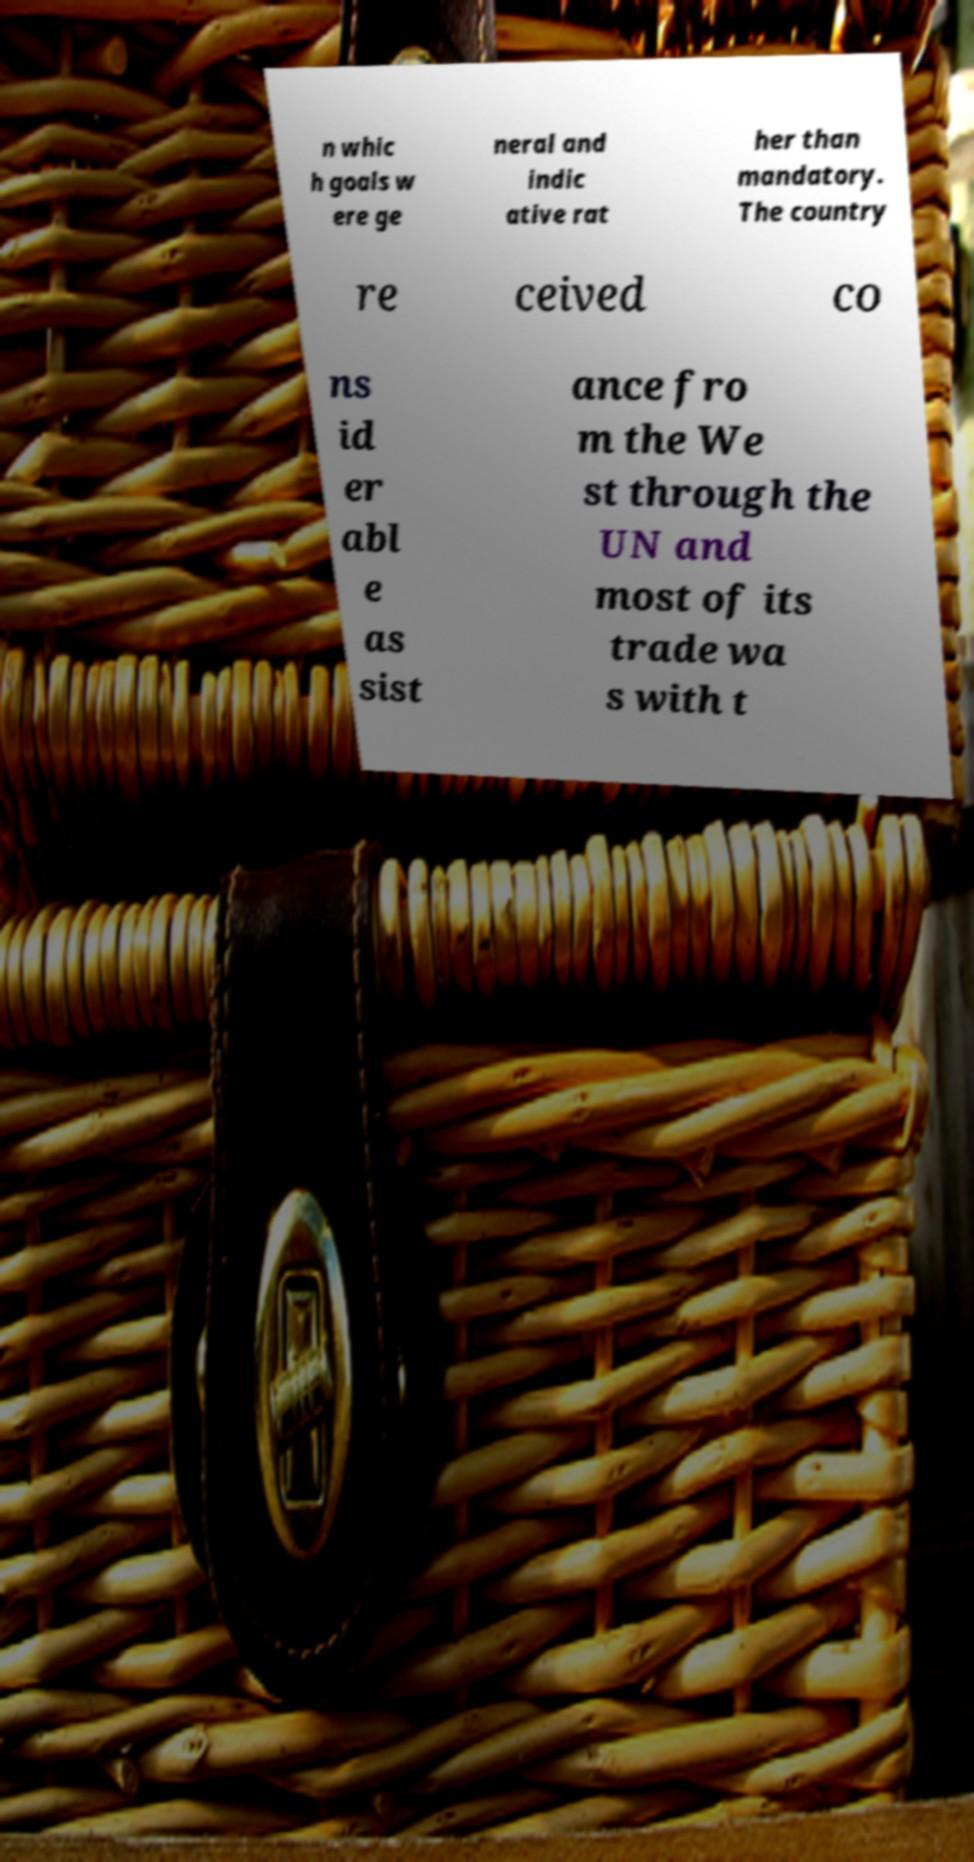Please identify and transcribe the text found in this image. n whic h goals w ere ge neral and indic ative rat her than mandatory. The country re ceived co ns id er abl e as sist ance fro m the We st through the UN and most of its trade wa s with t 